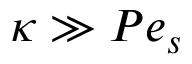Convert formula to latex. <formula><loc_0><loc_0><loc_500><loc_500>\kappa \gg P e _ { s }</formula> 